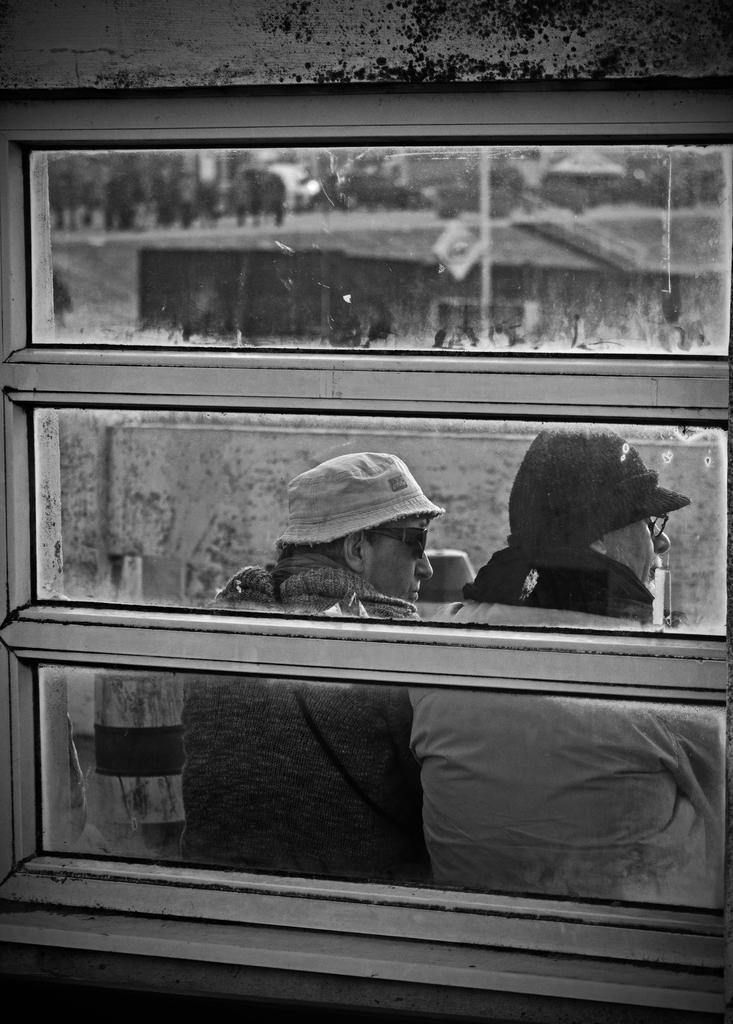What can be seen in the image that provides a view of the outside? There is a window in the image. What can be observed through the window? People are visible through the window glass. What type of dinner is being served on the crayon in the image? There is no dinner or crayon present in the image. 